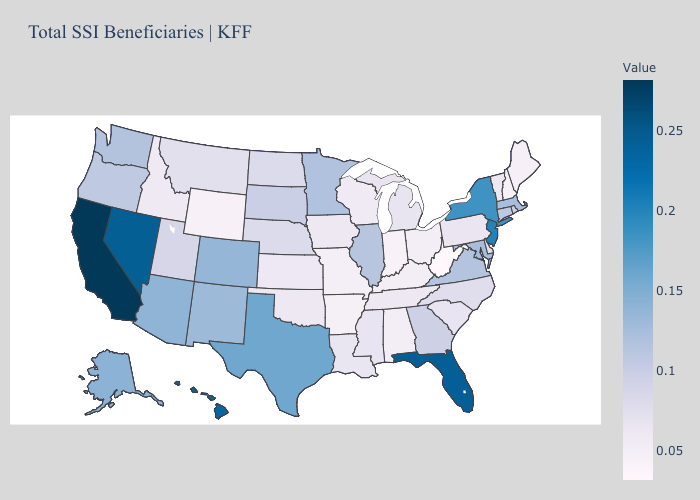Which states have the lowest value in the West?
Short answer required. Wyoming. Does Maryland have a higher value than California?
Give a very brief answer. No. Does Oregon have a higher value than Nevada?
Keep it brief. No. Among the states that border Texas , does New Mexico have the highest value?
Be succinct. Yes. Does New Hampshire have the lowest value in the Northeast?
Concise answer only. Yes. 